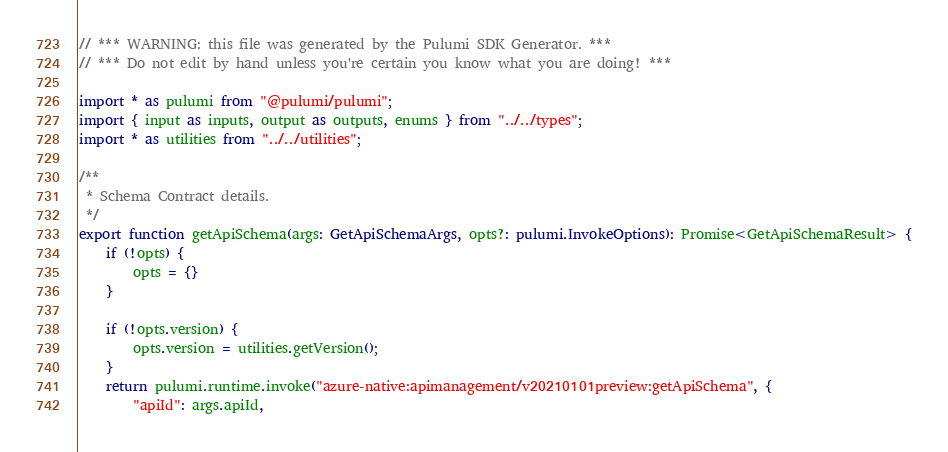<code> <loc_0><loc_0><loc_500><loc_500><_TypeScript_>// *** WARNING: this file was generated by the Pulumi SDK Generator. ***
// *** Do not edit by hand unless you're certain you know what you are doing! ***

import * as pulumi from "@pulumi/pulumi";
import { input as inputs, output as outputs, enums } from "../../types";
import * as utilities from "../../utilities";

/**
 * Schema Contract details.
 */
export function getApiSchema(args: GetApiSchemaArgs, opts?: pulumi.InvokeOptions): Promise<GetApiSchemaResult> {
    if (!opts) {
        opts = {}
    }

    if (!opts.version) {
        opts.version = utilities.getVersion();
    }
    return pulumi.runtime.invoke("azure-native:apimanagement/v20210101preview:getApiSchema", {
        "apiId": args.apiId,</code> 